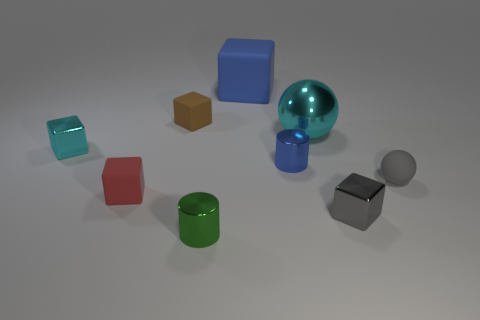Subtract all gray blocks. How many blocks are left? 4 Subtract all brown blocks. How many blocks are left? 4 Subtract 1 blocks. How many blocks are left? 4 Add 1 small green matte things. How many objects exist? 10 Subtract 0 purple cubes. How many objects are left? 9 Subtract all balls. How many objects are left? 7 Subtract all gray cylinders. Subtract all green blocks. How many cylinders are left? 2 Subtract all gray blocks. How many green cylinders are left? 1 Subtract all gray cubes. Subtract all brown cubes. How many objects are left? 7 Add 7 tiny blue metallic things. How many tiny blue metallic things are left? 8 